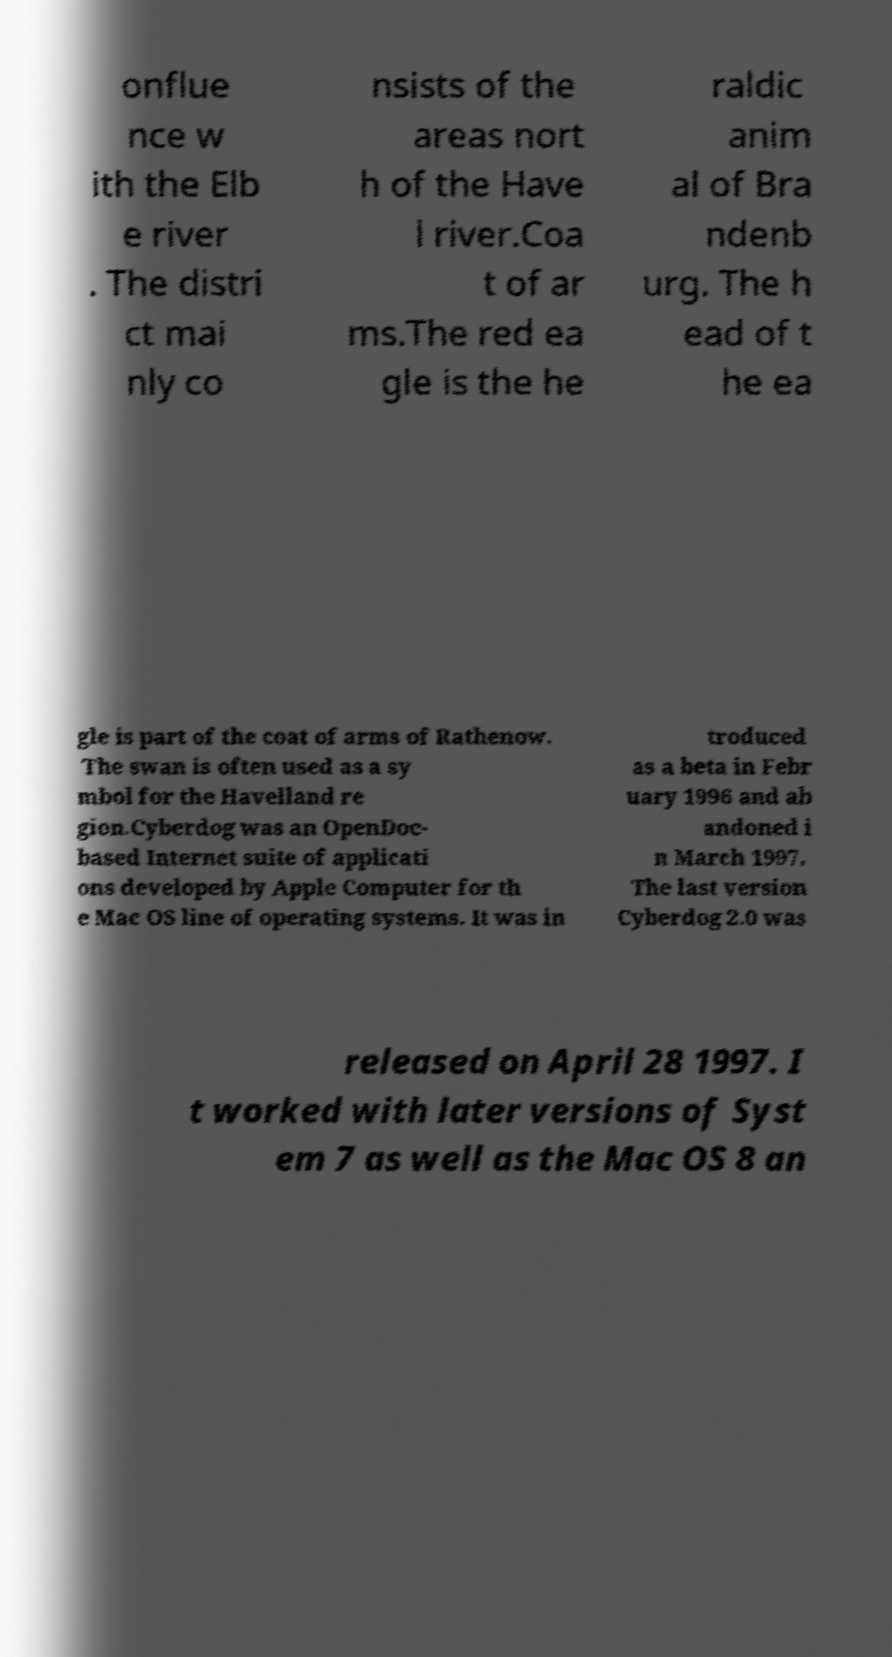There's text embedded in this image that I need extracted. Can you transcribe it verbatim? onflue nce w ith the Elb e river . The distri ct mai nly co nsists of the areas nort h of the Have l river.Coa t of ar ms.The red ea gle is the he raldic anim al of Bra ndenb urg. The h ead of t he ea gle is part of the coat of arms of Rathenow. The swan is often used as a sy mbol for the Havelland re gion.Cyberdog was an OpenDoc- based Internet suite of applicati ons developed by Apple Computer for th e Mac OS line of operating systems. It was in troduced as a beta in Febr uary 1996 and ab andoned i n March 1997. The last version Cyberdog 2.0 was released on April 28 1997. I t worked with later versions of Syst em 7 as well as the Mac OS 8 an 